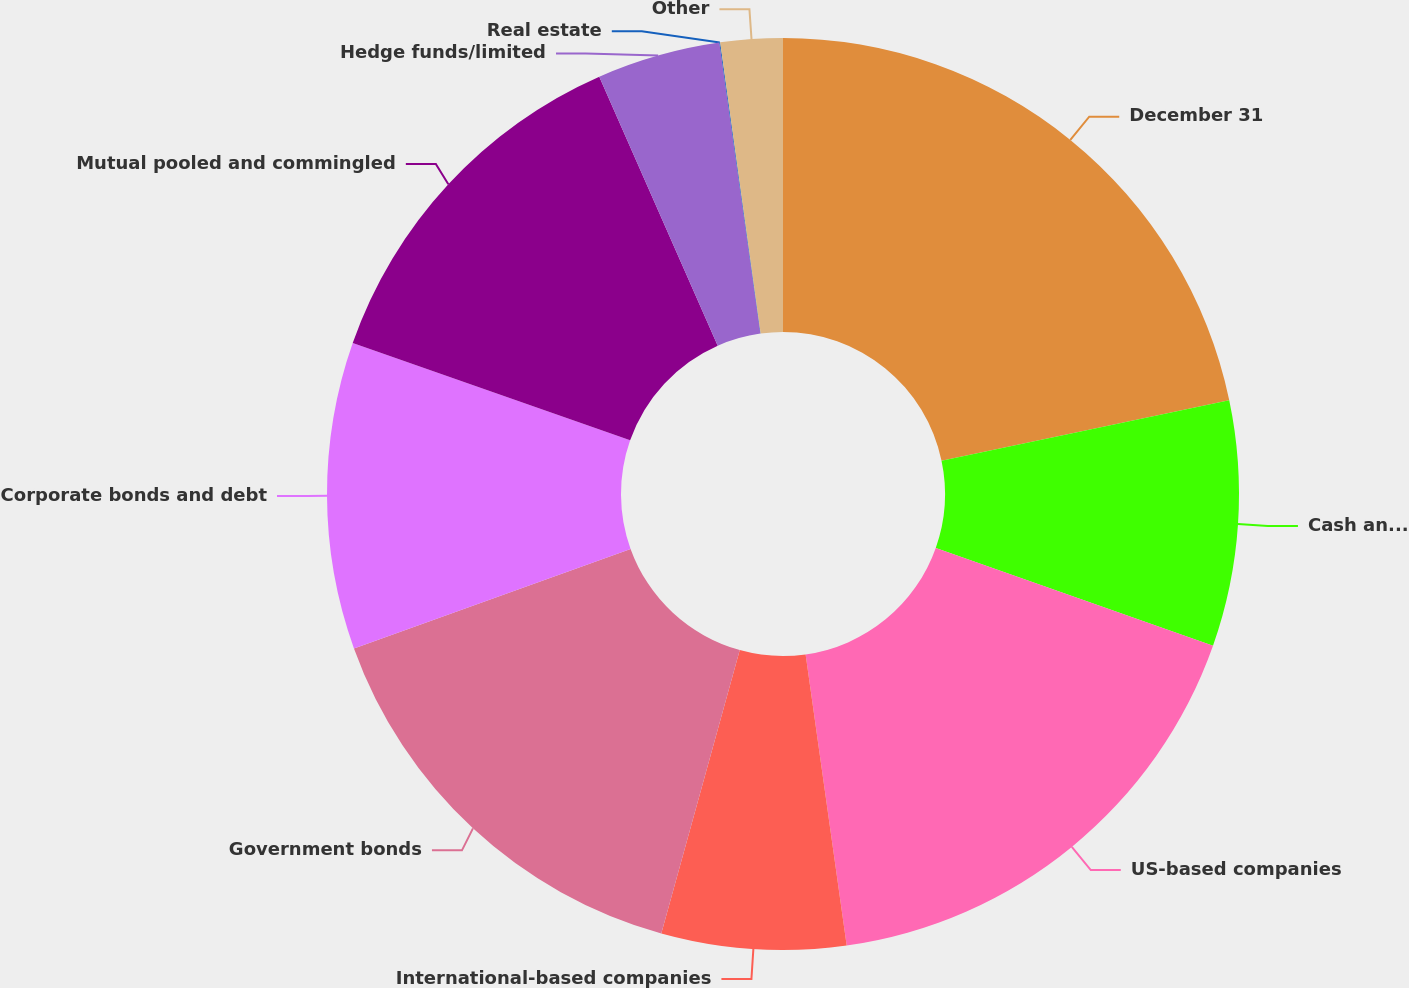Convert chart. <chart><loc_0><loc_0><loc_500><loc_500><pie_chart><fcel>December 31<fcel>Cash and cash equivalents<fcel>US-based companies<fcel>International-based companies<fcel>Government bonds<fcel>Corporate bonds and debt<fcel>Mutual pooled and commingled<fcel>Hedge funds/limited<fcel>Real estate<fcel>Other<nl><fcel>21.7%<fcel>8.7%<fcel>17.37%<fcel>6.53%<fcel>15.2%<fcel>10.87%<fcel>13.03%<fcel>4.37%<fcel>0.03%<fcel>2.2%<nl></chart> 